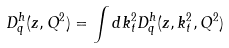Convert formula to latex. <formula><loc_0><loc_0><loc_500><loc_500>D _ { q } ^ { h } ( z , Q ^ { 2 } ) = \int d k _ { t } ^ { 2 } D _ { q } ^ { h } ( z , k _ { t } ^ { 2 } , Q ^ { 2 } )</formula> 